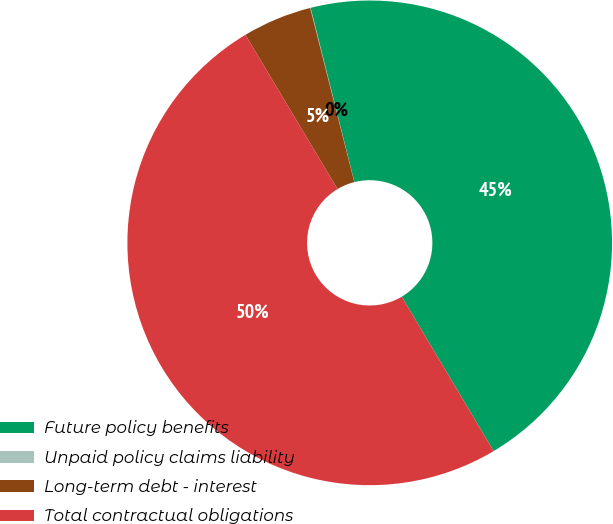<chart> <loc_0><loc_0><loc_500><loc_500><pie_chart><fcel>Future policy benefits<fcel>Unpaid policy claims liability<fcel>Long-term debt - interest<fcel>Total contractual obligations<nl><fcel>45.38%<fcel>0.03%<fcel>4.62%<fcel>49.97%<nl></chart> 